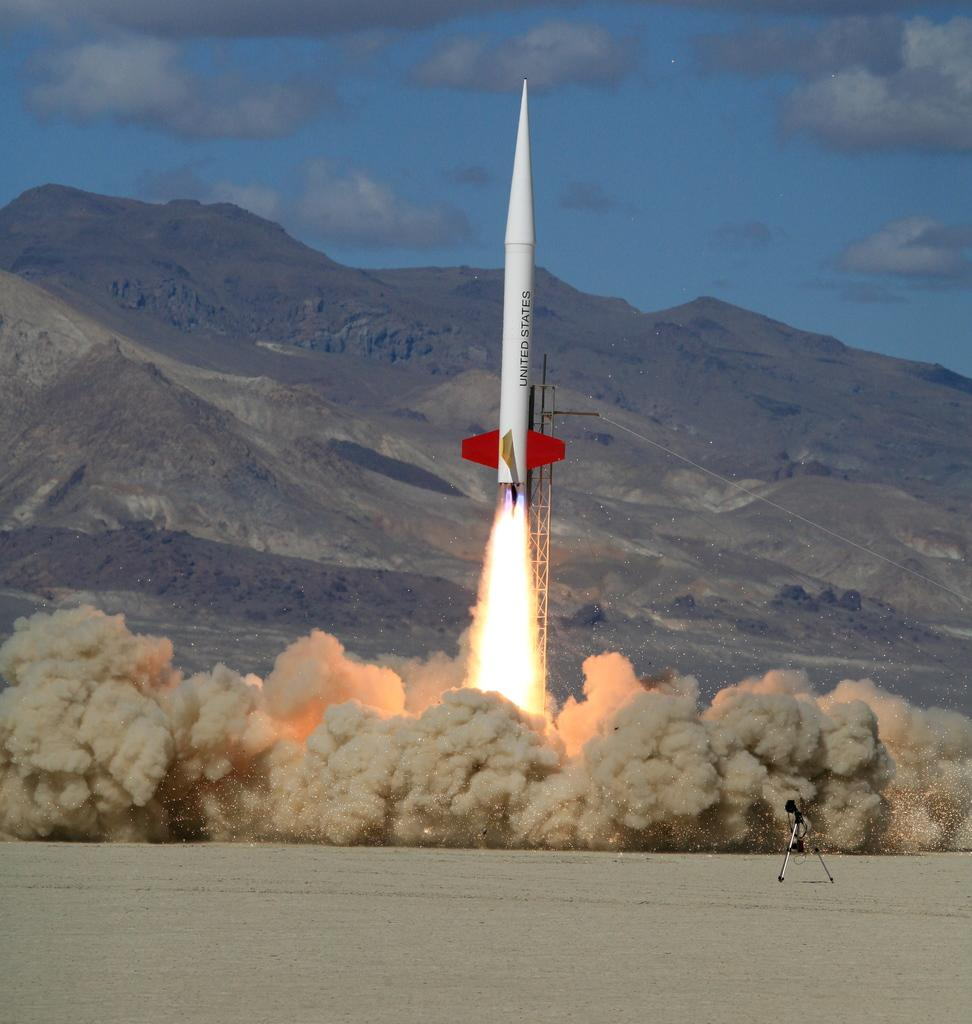<image>
Provide a brief description of the given image. a rocket with the words United States is launching into that air 